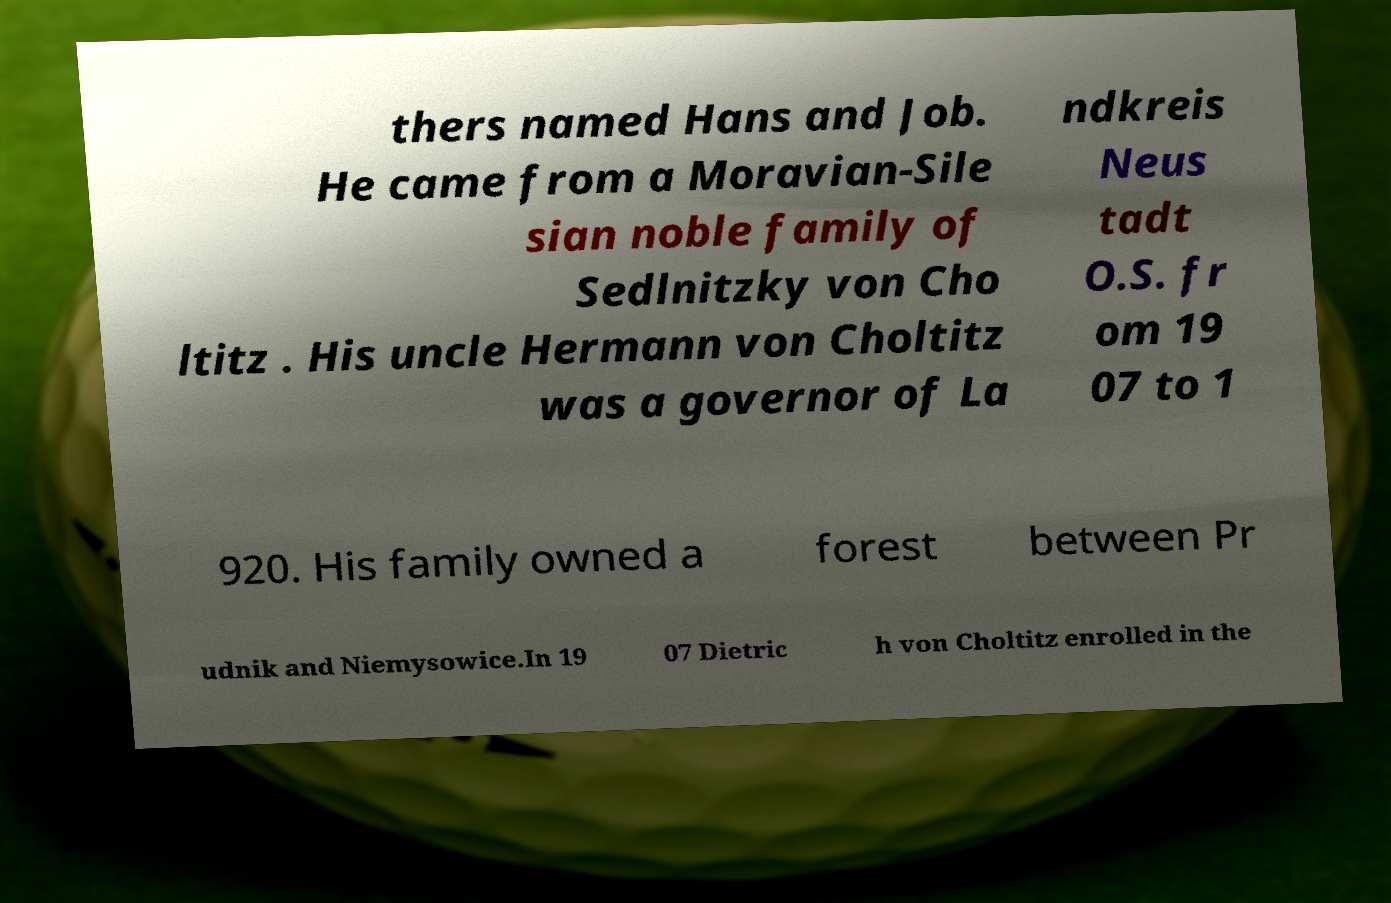Could you assist in decoding the text presented in this image and type it out clearly? thers named Hans and Job. He came from a Moravian-Sile sian noble family of Sedlnitzky von Cho ltitz . His uncle Hermann von Choltitz was a governor of La ndkreis Neus tadt O.S. fr om 19 07 to 1 920. His family owned a forest between Pr udnik and Niemysowice.In 19 07 Dietric h von Choltitz enrolled in the 